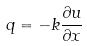<formula> <loc_0><loc_0><loc_500><loc_500>q = - k \frac { \partial u } { \partial x }</formula> 